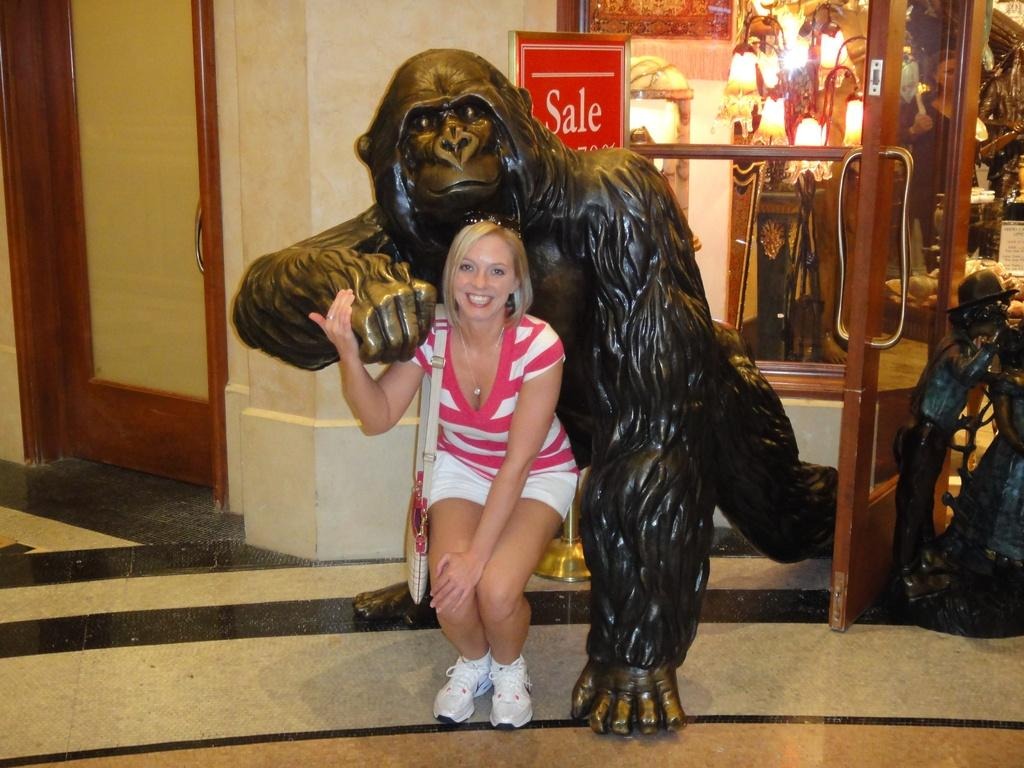Who is present in the image? There is a woman in the image. What is the woman doing in the image? The woman is smiling and posing with a King Kong statue. What can be seen behind the statue? There are doors and windows visible behind the statue. How much attention does the bridge receive in the image? There is no bridge present in the image, so it is not possible to determine the amount of attention it receives. 